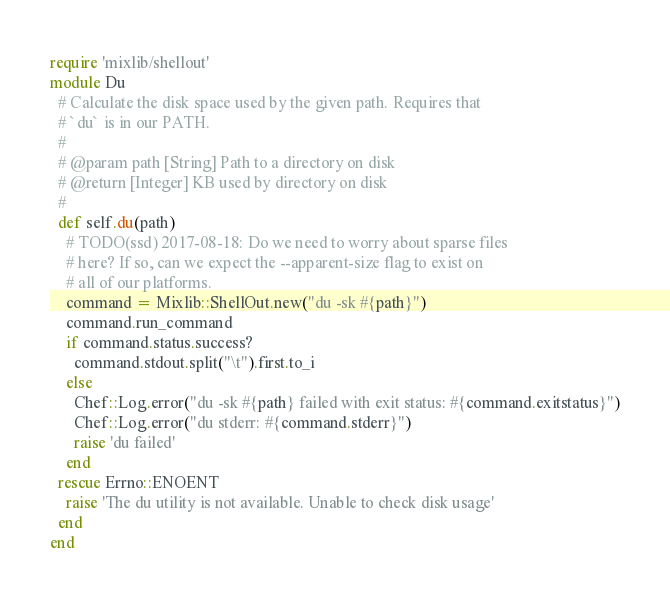Convert code to text. <code><loc_0><loc_0><loc_500><loc_500><_Ruby_>require 'mixlib/shellout'
module Du
  # Calculate the disk space used by the given path. Requires that
  # `du` is in our PATH.
  #
  # @param path [String] Path to a directory on disk
  # @return [Integer] KB used by directory on disk
  #
  def self.du(path)
    # TODO(ssd) 2017-08-18: Do we need to worry about sparse files
    # here? If so, can we expect the --apparent-size flag to exist on
    # all of our platforms.
    command = Mixlib::ShellOut.new("du -sk #{path}")
    command.run_command
    if command.status.success?
      command.stdout.split("\t").first.to_i
    else
      Chef::Log.error("du -sk #{path} failed with exit status: #{command.exitstatus}")
      Chef::Log.error("du stderr: #{command.stderr}")
      raise 'du failed'
    end
  rescue Errno::ENOENT
    raise 'The du utility is not available. Unable to check disk usage'
  end
end
</code> 